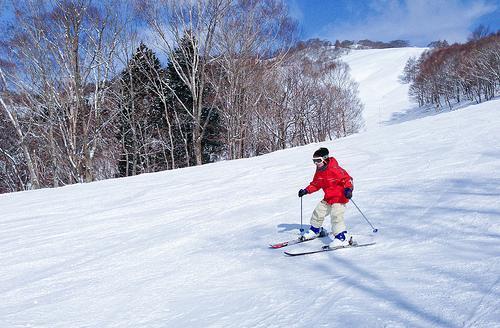How many people are in the picture?
Give a very brief answer. 1. 